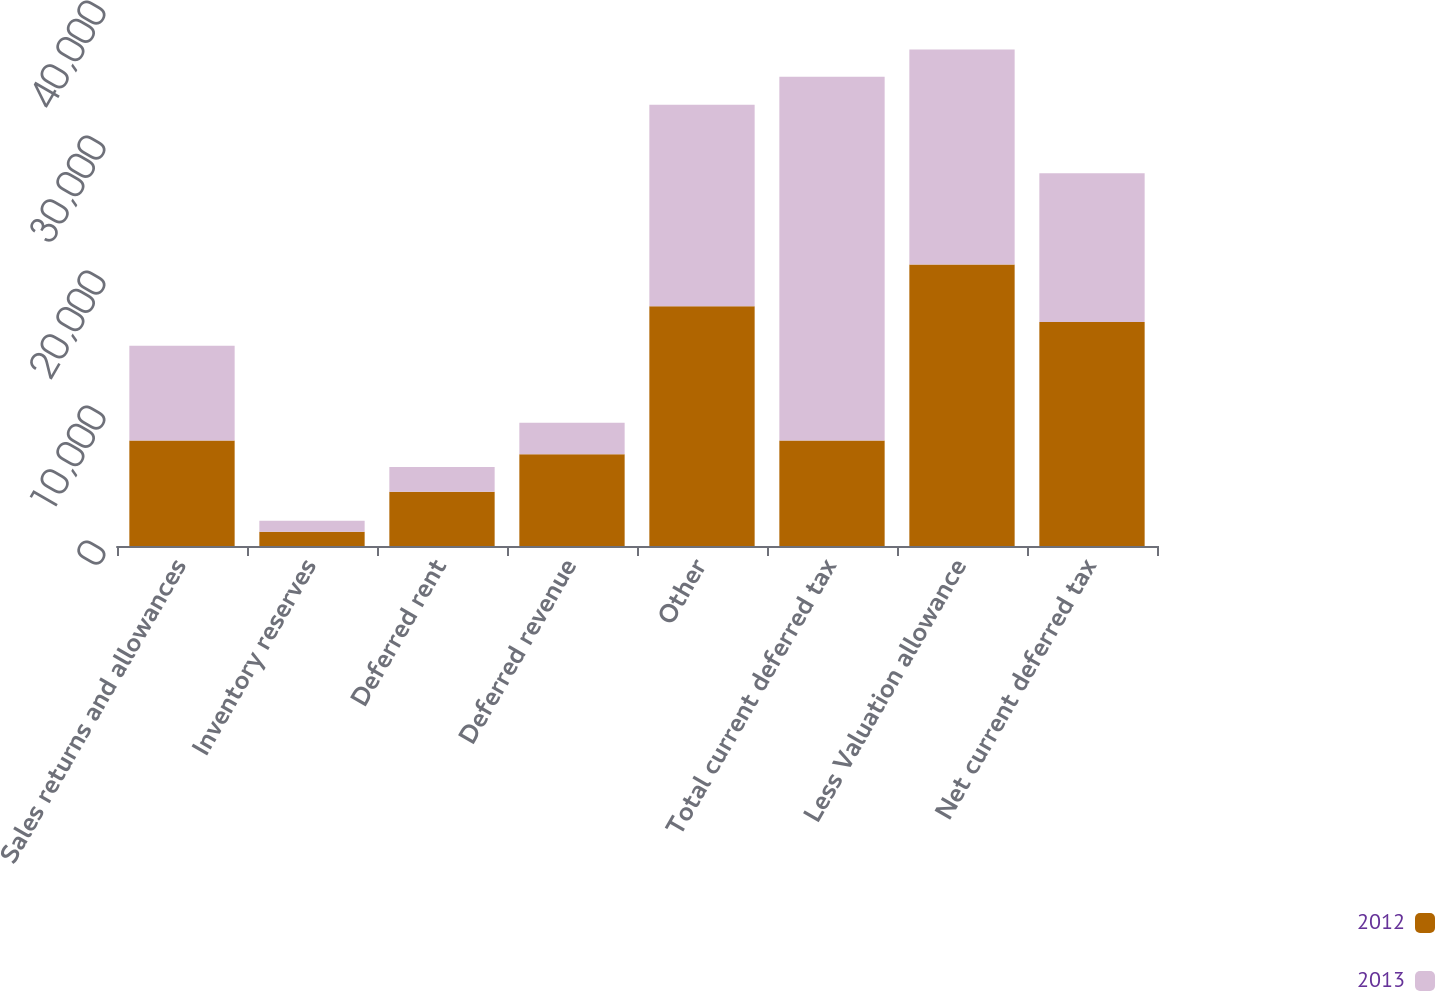Convert chart to OTSL. <chart><loc_0><loc_0><loc_500><loc_500><stacked_bar_chart><ecel><fcel>Sales returns and allowances<fcel>Inventory reserves<fcel>Deferred rent<fcel>Deferred revenue<fcel>Other<fcel>Total current deferred tax<fcel>Less Valuation allowance<fcel>Net current deferred tax<nl><fcel>2012<fcel>7823<fcel>1054<fcel>4017<fcel>6790<fcel>17763<fcel>7823<fcel>20858<fcel>16589<nl><fcel>2013<fcel>7017<fcel>815<fcel>1843<fcel>2339<fcel>14920<fcel>26934<fcel>15921<fcel>11013<nl></chart> 